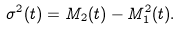<formula> <loc_0><loc_0><loc_500><loc_500>\sigma ^ { 2 } ( t ) = M _ { 2 } ( t ) - M _ { 1 } ^ { 2 } ( t ) .</formula> 